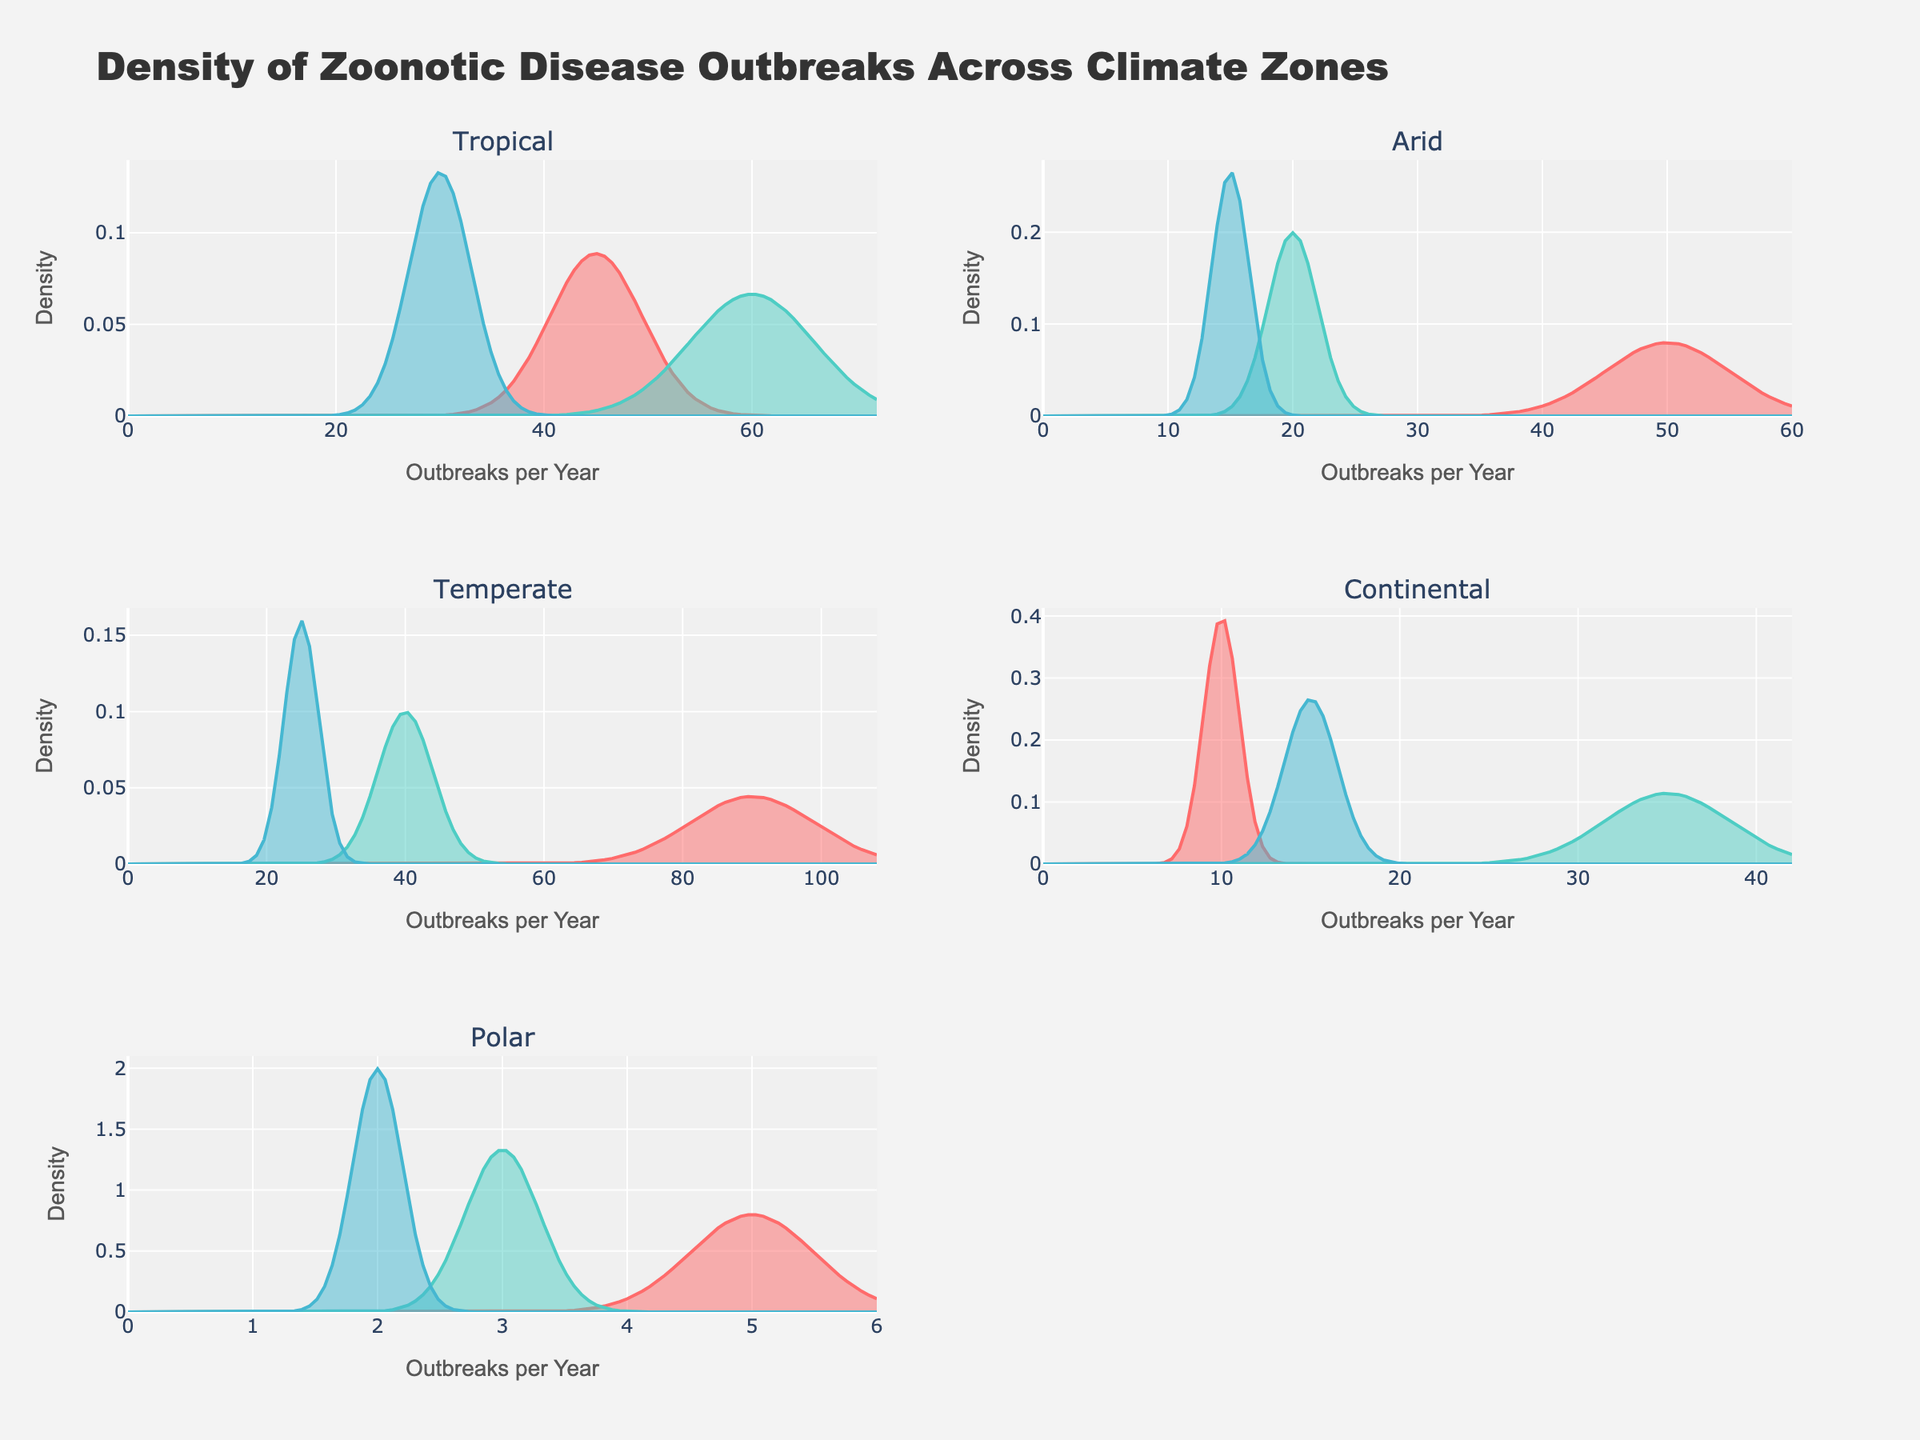What's the title of the plot? The title of the plot is usually displayed prominently at the top of the figure. In this case, based on the provided data and code, the title is "Density of Zoonotic Disease Outbreaks Across Climate Zones."
Answer: Density of Zoonotic Disease Outbreaks Across Climate Zones Which climate zone has the highest number of zoonotic disease outbreaks per year for a single disease? By examining the figure, the highest density peak represents the disease with the highest outbreaks per year. The temperate zone has Lyme Disease with 90 outbreaks per year, indicating the highest number.
Answer: Temperate What is the range of outbreaks per year in the polar climate zone? According to the figure, we can see different density distributions representing different diseases in the polar zone. The range can be determined by noting the lowest and highest outbreak values, which are 2 (Anthrax) and 5 (Echinococcosis).
Answer: 2 to 5 How is the outbreak frequency of rabies spread across different climate zones? To answer this, we look at which climate zones have rabies outbreaks and the associated frequencies. In the figure, Rabies appears both in the Temperate zone with 40 outbreaks per year and in the Polar zone with 3 outbreaks per year.
Answer: Temperate: 40, Polar: 3 Which zoonotic disease has the widest density spread in the Tropical climate zone? The distribution width can be assessed by examining the spread of the density curve. Dengue, with 60 outbreaks per year, has the widest density curve, indicating variation around this center value compared to Malaria and Leptospirosis.
Answer: Dengue Is the density peak for Echinococcosis in the polar zone higher or lower than the density peak for Crimean-Congo Hemorrhagic Fever in the arid zone? Comparing the relative heights of the density peaks of Echinococcosis (Polar, 5 outbreaks/year) and CCHF (Arid, 20 outbreaks/year), we find that the latter has a higher peak.
Answer: Lower What is the average number of outbreaks per year for diseases in the continental zone? We sum the outbreaks per year for Hantavirus (10), West Nile Fever (35), and Brucellosis (15), then divide by the number of diseases. (10 + 35 + 15) / 3 = 20.
Answer: 20 Which climate zone shows the most diverse range of zoonotic diseases? Diversity in this context can be assessed by counting the number of diseases present in each climate zone. The code plots show Tropical, Arid, Temperate, Continental and Polar zones. The Tropical zone with three diseases (Malaria, Dengue, Leptospirosis) or Temperate zone with three diseases (Lyme Disease, Rabies, Erysipeloid) show the widest range.
Answer: Tropical or Temperate Which zoonotic disease has the lowest frequency of outbreaks per year in any climate zone? By examining the bottom end of the density plots in all climate zones, Anthrax in the Polar zone stands out with only 2 outbreaks per year.
Answer: Anthrax in Polar zone What is the relationship between climate zones and the density spread of zoonotic disease outbreaks? A comprehensive analysis involves comparing density curves across different climate zones. Wider spreads indicate more variability in outbreaks per year within that zone. Generally, diseases in Tropical zones show wider spreads compared to narrower, more consistent densities seen in Polar zones.
Answer: Variable spread across zones, typically wider in Tropical 